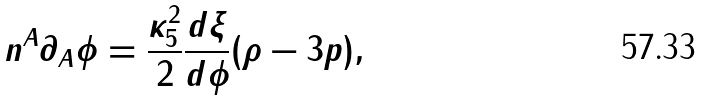Convert formula to latex. <formula><loc_0><loc_0><loc_500><loc_500>n ^ { A } \partial _ { A } \phi = \frac { \kappa _ { 5 } ^ { 2 } } { 2 } \frac { d \xi } { d \phi } ( \rho - 3 p ) ,</formula> 